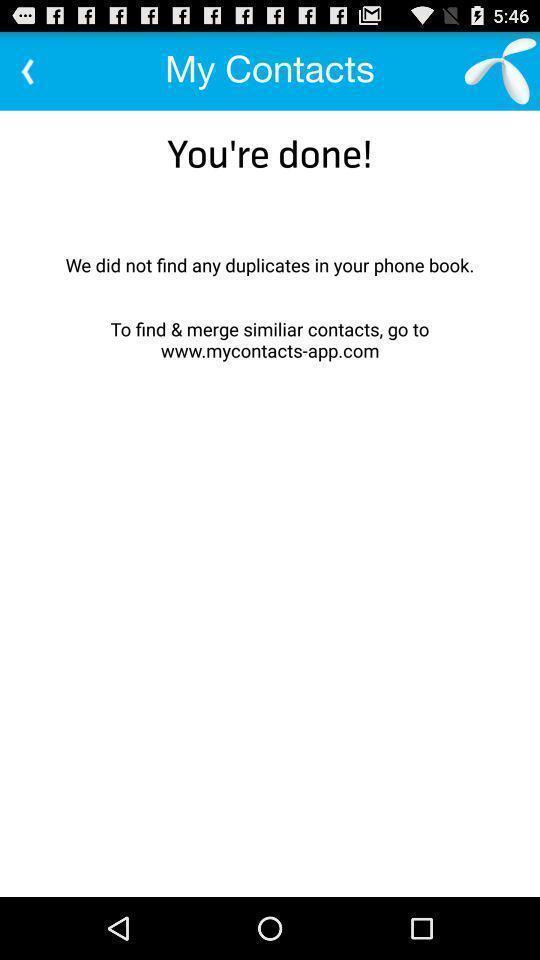Tell me what you see in this picture. Screen showing you 're done. 